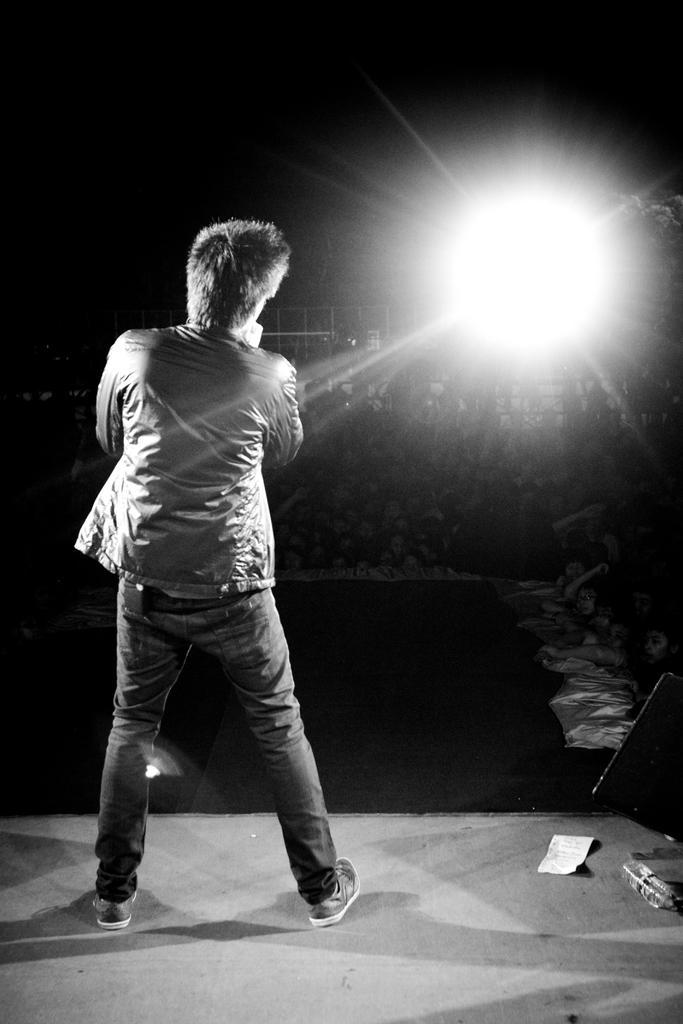Could you give a brief overview of what you see in this image? On the left there is a person standing. On the right we can see light. At the top it is dark. In the middle of the picture it is looking like a fencing. 